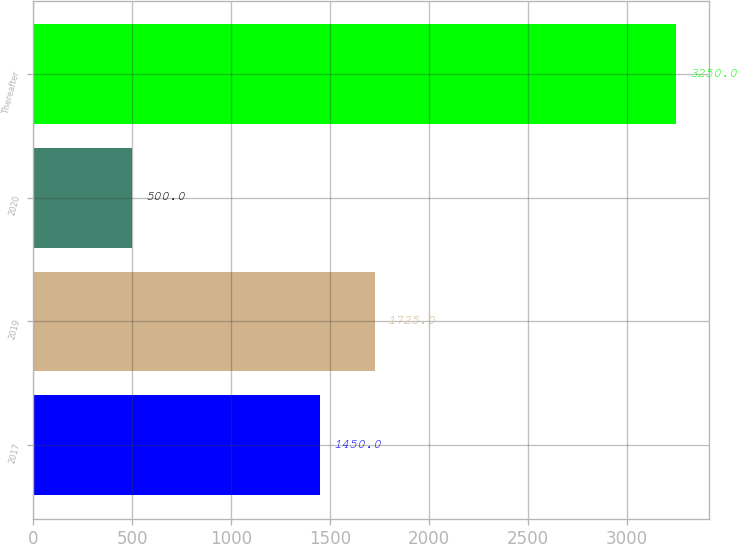Convert chart to OTSL. <chart><loc_0><loc_0><loc_500><loc_500><bar_chart><fcel>2017<fcel>2019<fcel>2020<fcel>Thereafter<nl><fcel>1450<fcel>1725<fcel>500<fcel>3250<nl></chart> 